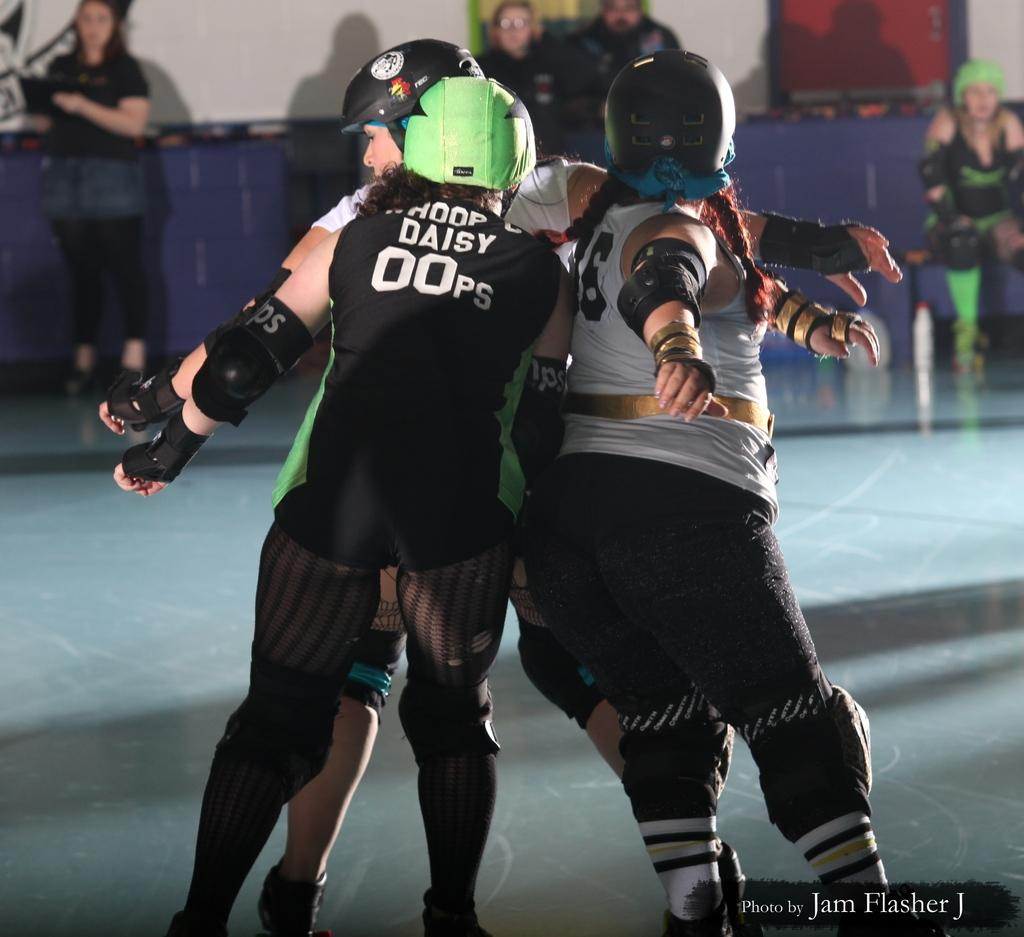How many people are present in the image? There are few people in the image. What is the color of the wall visible in the image? The wall in the image is white. Can you see any snails crawling on the white wall in the image? There are no snails visible on the white wall in the image. What type of ink is being used by the people in the image? There is no indication of ink or any writing activity in the image. 